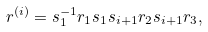Convert formula to latex. <formula><loc_0><loc_0><loc_500><loc_500>r ^ { ( i ) } = s ^ { - 1 } _ { 1 } r _ { 1 } s _ { 1 } s _ { i + 1 } r _ { 2 } s _ { i + 1 } r _ { 3 } ,</formula> 